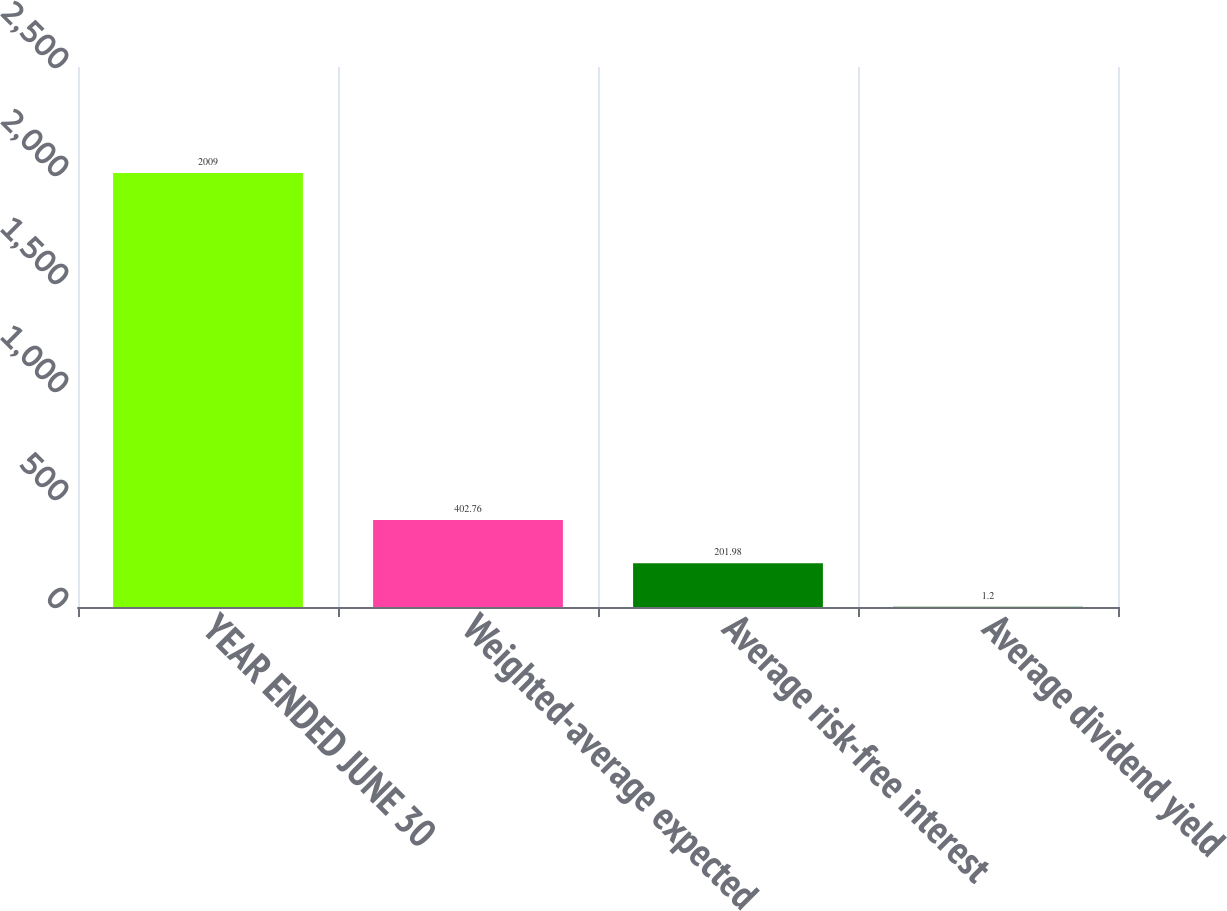<chart> <loc_0><loc_0><loc_500><loc_500><bar_chart><fcel>YEAR ENDED JUNE 30<fcel>Weighted-average expected<fcel>Average risk-free interest<fcel>Average dividend yield<nl><fcel>2009<fcel>402.76<fcel>201.98<fcel>1.2<nl></chart> 